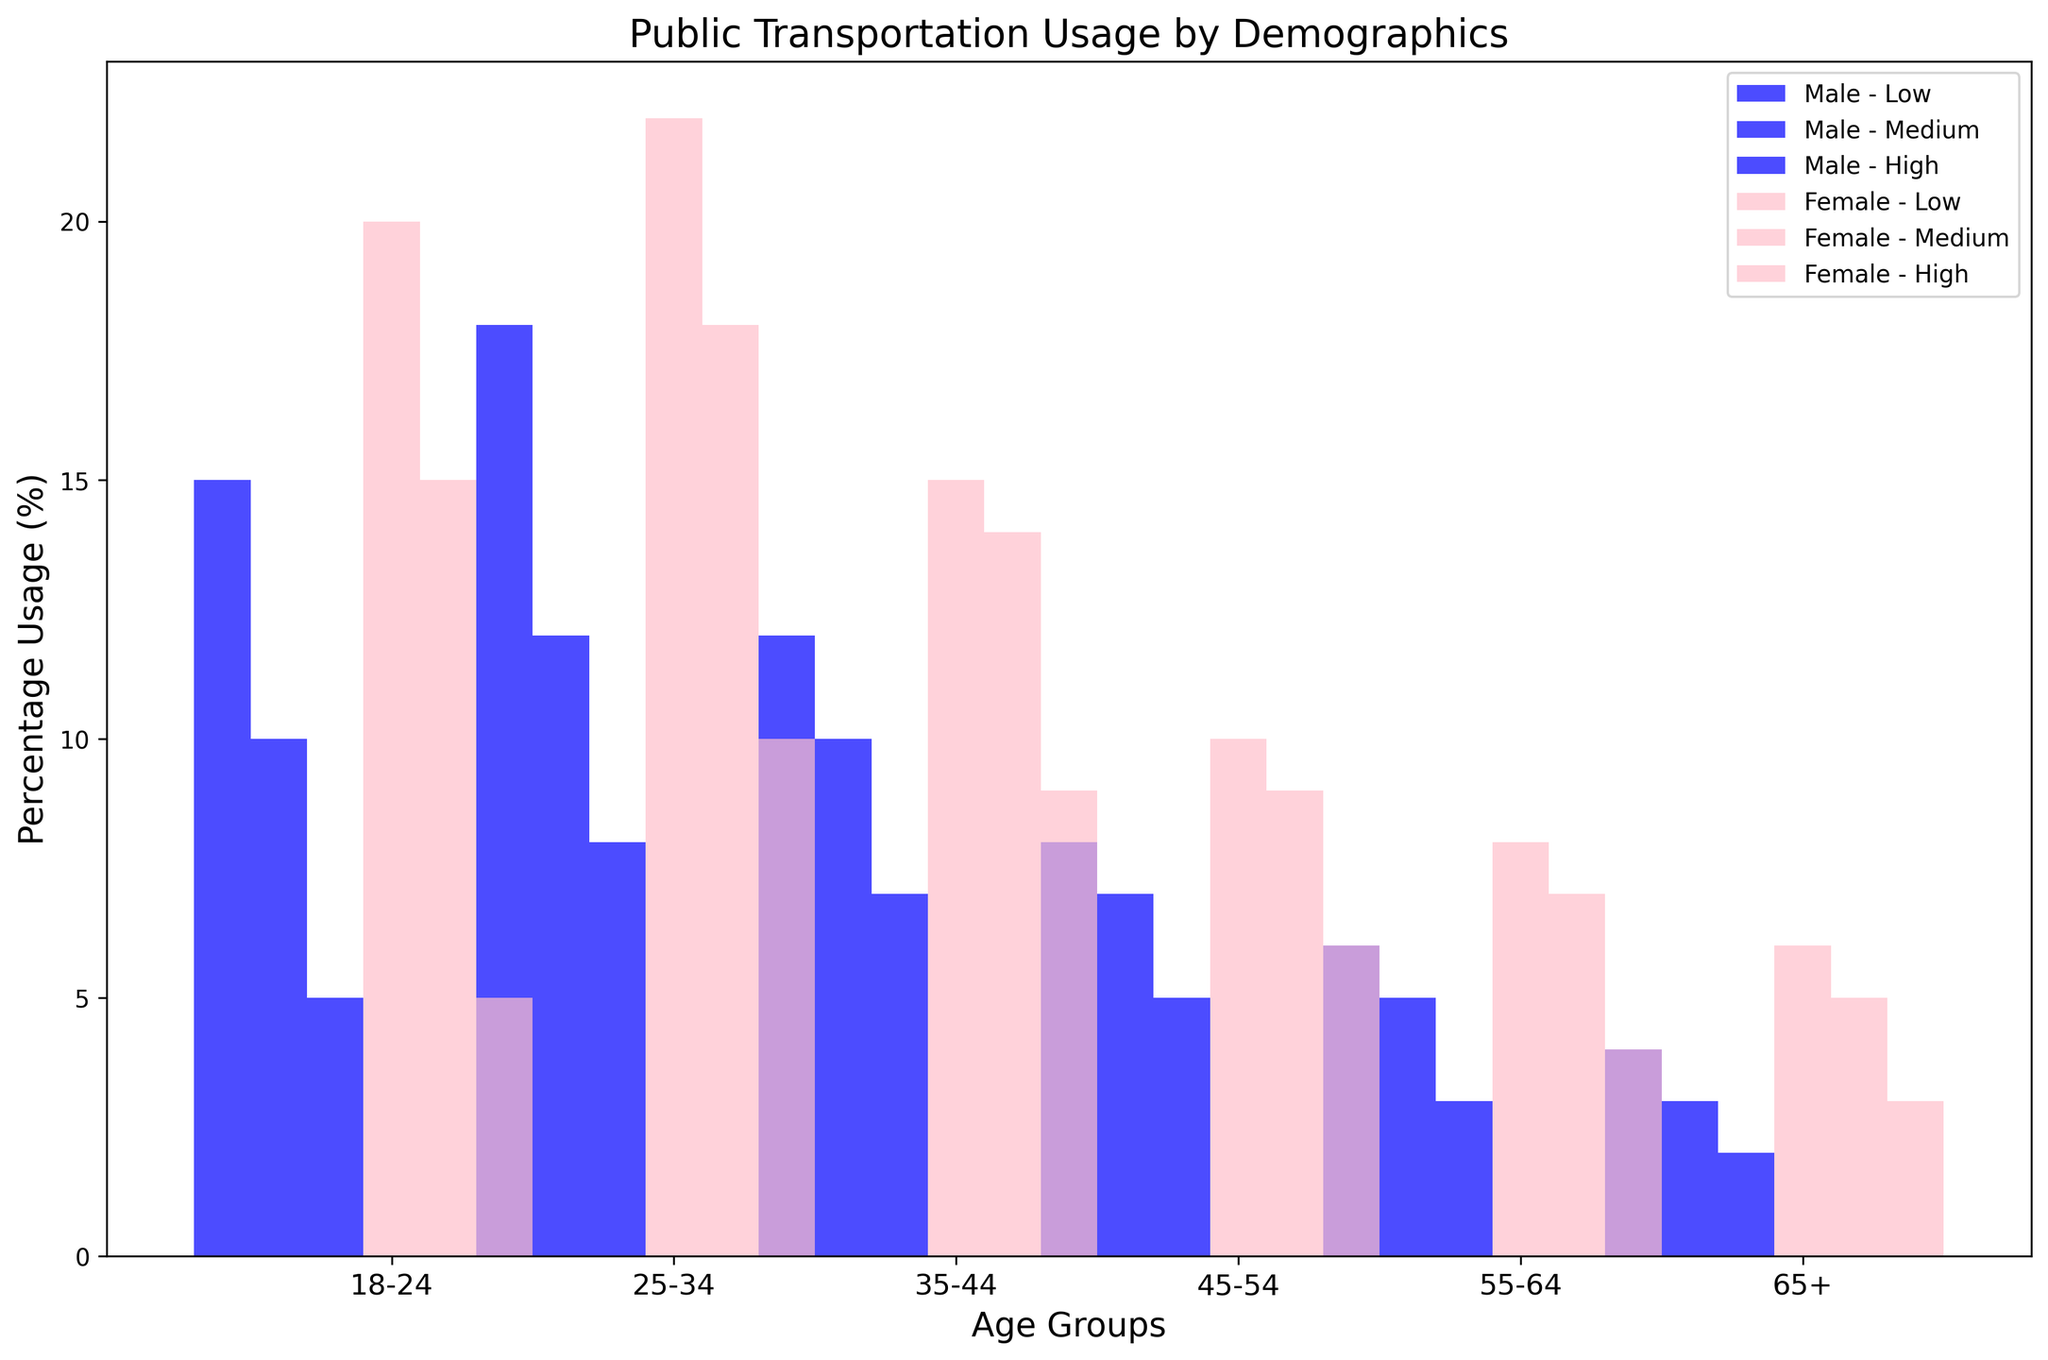Which age group has the highest percentage usage of public transportation among low-income females? To determine this, we need to compare the percentage usage values for low-income females across all age groups. The values are: 18-24: 20%, 25-34: 22%, 35-44: 15%, 45-54: 10%, 55-64: 8%, 65+: 6%. The highest value is 22% in the 25-34 age group.
Answer: 25-34 What is the combined percentage usage of public transportation for medium-income males aged between 25 and 44? First, look at the medium-income males in the 25-34 and 35-44 age groups. The usage percentages are 12% and 10% respectively. Adding these gives: 12% + 10% = 22%.
Answer: 22% Which gender and income level combination has the lowest public transportation usage in the 65+ age group? For the 65+ age group, compare the usage percentages for different gender and income levels: Male Low: 4%, Male Medium: 3%, Male High: 2%, Female Low: 6%, Female Medium: 5%, Female High: 3%. The lowest is Male High with 2%.
Answer: Male High How does the percentage usage of public transportation for high-income females aged 18-24 compare to that of high-income males aged the same? For the 18-24 age group, high-income females have a usage percentage of 5%, and high-income males also have 5%. They are equal.
Answer: Equal What is the percent difference in public transportation usage between low-income males aged 55-64 and high-income females in the same age group? The percentages for low-income males aged 55-64 is 6%, and for high-income females aged 55-64 is 4%. The percent difference is calculated as (6% - 4%) / 6% * 100% = 33.33%.
Answer: 33.33% Which gender and income level combination is the most consistent in public transportation usage across all age groups? To find the most consistent combination, look for the gender and income level combination with the least variation across all age groups. By examining the data, medium-income males have relatively stable usage percentages (10%, 12%, 10%, 7%, 5%, 3%), indicating consistency.
Answer: Medium-income males In the 35-44 age group, who uses public transportation more: medium-income females or low-income males? For the 35-44 age group, medium-income females have a percentage of 14%, and low-income males have 12%. Medium-income females use public transportation more.
Answer: Medium-income females 